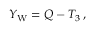<formula> <loc_0><loc_0><loc_500><loc_500>Y _ { W } = Q - T _ { 3 } \, ,</formula> 